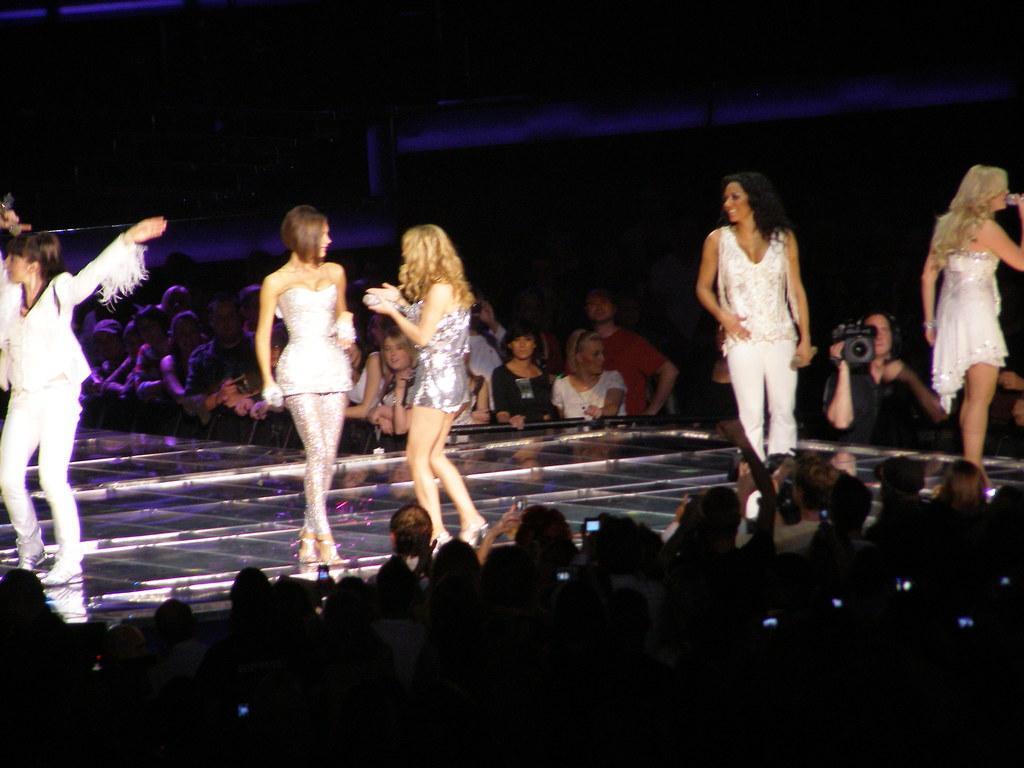How would you summarize this image in a sentence or two? In the picture are women standing on the stage, around the stage there are many people present, there is a person holding a video camera. 